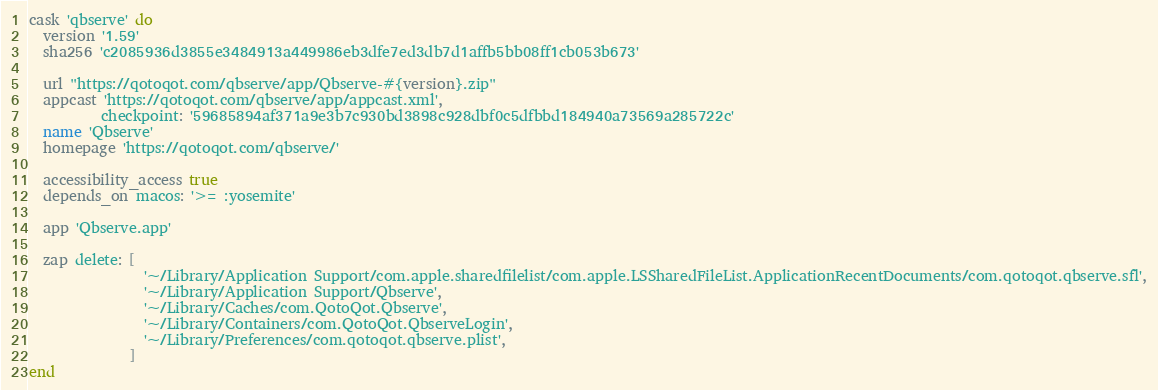Convert code to text. <code><loc_0><loc_0><loc_500><loc_500><_Ruby_>cask 'qbserve' do
  version '1.59'
  sha256 'c2085936d3855e3484913a449986eb3dfe7ed3db7d1affb5bb08ff1cb053b673'

  url "https://qotoqot.com/qbserve/app/Qbserve-#{version}.zip"
  appcast 'https://qotoqot.com/qbserve/app/appcast.xml',
          checkpoint: '59685894af371a9e3b7c930bd3898c928dbf0c5dfbbd184940a73569a285722c'
  name 'Qbserve'
  homepage 'https://qotoqot.com/qbserve/'

  accessibility_access true
  depends_on macos: '>= :yosemite'

  app 'Qbserve.app'

  zap delete: [
                '~/Library/Application Support/com.apple.sharedfilelist/com.apple.LSSharedFileList.ApplicationRecentDocuments/com.qotoqot.qbserve.sfl',
                '~/Library/Application Support/Qbserve',
                '~/Library/Caches/com.QotoQot.Qbserve',
                '~/Library/Containers/com.QotoQot.QbserveLogin',
                '~/Library/Preferences/com.qotoqot.qbserve.plist',
              ]
end
</code> 